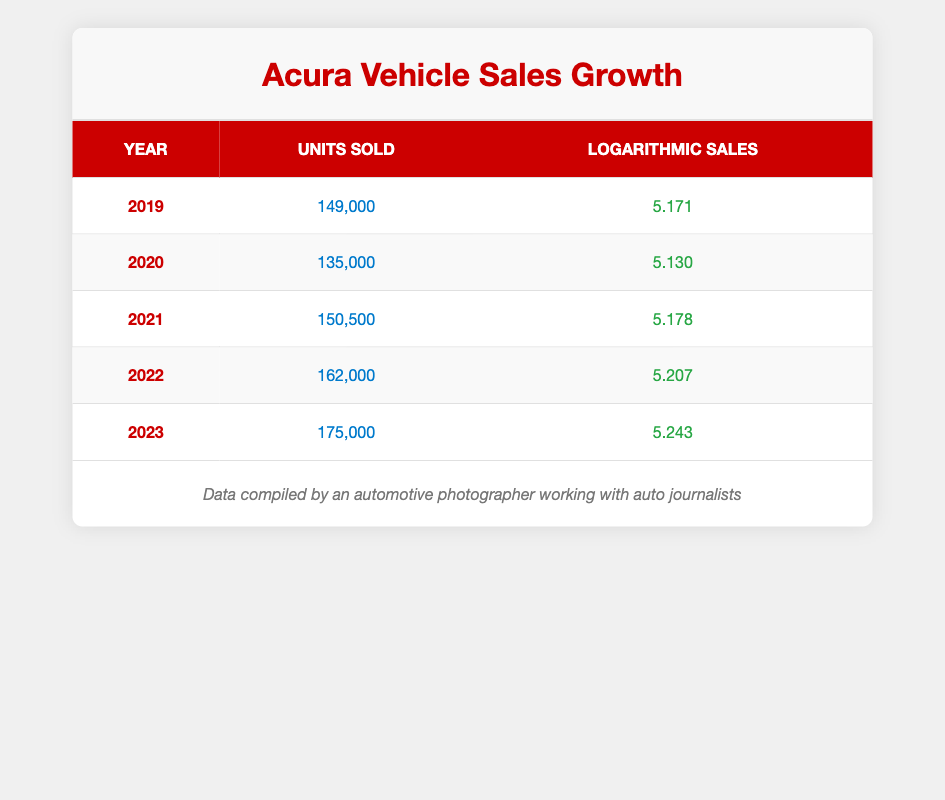What was the highest number of units sold for Acura vehicles in the past five years? The units sold for each year are as follows: 149,000 in 2019, 135,000 in 2020, 150,500 in 2021, 162,000 in 2022, and 175,000 in 2023. The highest number is 175,000 in 2023.
Answer: 175,000 In which year did Acura vehicles experience the lowest sales? The units sold for each year show that 2019 had 149,000, 2020 had 135,000, 2021 had 150,500, 2022 had 162,000, and 2023 had 175,000. The lowest sales occurred in 2020 with 135,000 units sold.
Answer: 2020 What is the average number of units sold over the five years? To calculate the average, we add all the units sold: 149,000 + 135,000 + 150,500 + 162,000 + 175,000 = 771,500. Then we divide by the five years, which gives 771,500 / 5 = 154,300.
Answer: 154,300 Did the sales growth of Acura vehicles increase consistently each year? We observe the units sold year by year: in 2019, 149,000; in 2020, 135,000; in 2021, 150,500; in 2022, 162,000; and in 2023, 175,000. Sales decreased from 2019 to 2020, indicating it was not consistent each year.
Answer: No What was the change in logarithmic sales from 2021 to 2023? The logarithmic sales in 2021 was 5.178, and in 2023 it increased to 5.243. To find the change, we subtract: 5.243 - 5.178 = 0.065.
Answer: 0.065 